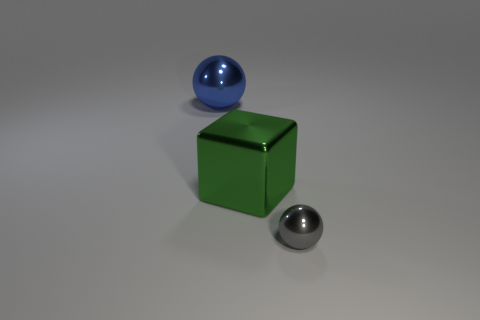Add 2 red metallic cylinders. How many objects exist? 5 Subtract all cubes. How many objects are left? 2 Subtract 0 yellow balls. How many objects are left? 3 Subtract all large gray matte things. Subtract all large blue spheres. How many objects are left? 2 Add 3 tiny gray metallic objects. How many tiny gray metallic objects are left? 4 Add 3 small spheres. How many small spheres exist? 4 